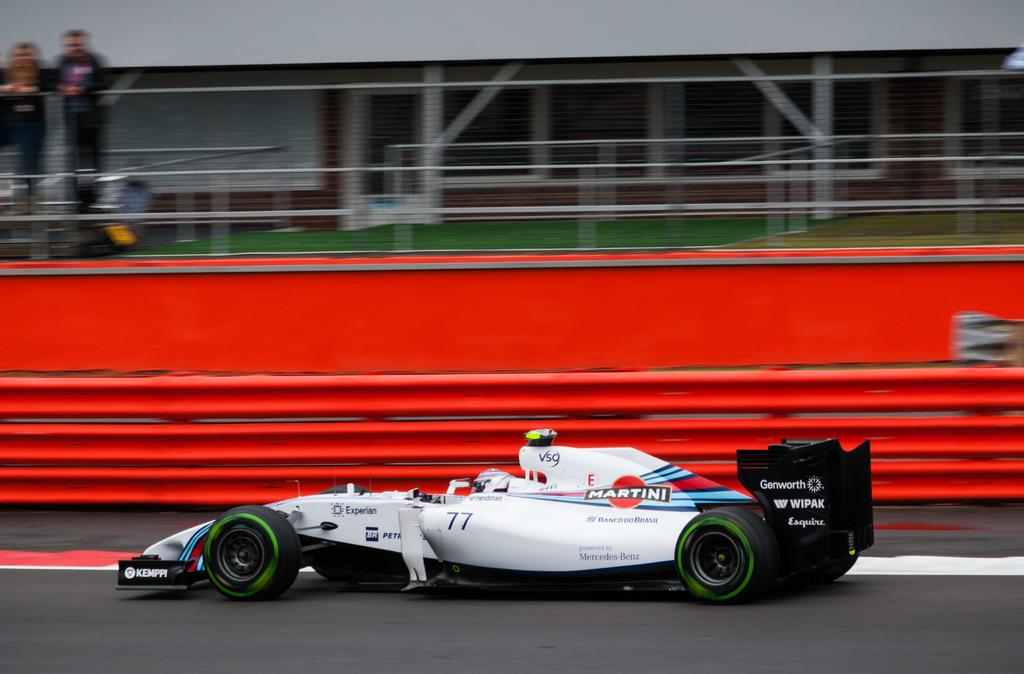What type of vehicle is on the road in the image? There is a sports car on the road in the image. What can be seen in the background of the image? There is a boundary and a building in the background of the image. How many people are present in the image? Two people are standing in the image. Can you describe the overall appearance of the image? The image appears hazy. What type of harmony is being played by the mom in the image? There is no mom or harmony present in the image. 